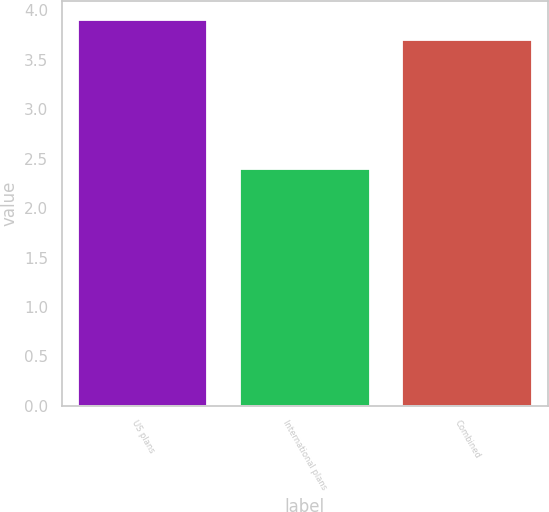Convert chart. <chart><loc_0><loc_0><loc_500><loc_500><bar_chart><fcel>US plans<fcel>International plans<fcel>Combined<nl><fcel>3.9<fcel>2.4<fcel>3.7<nl></chart> 